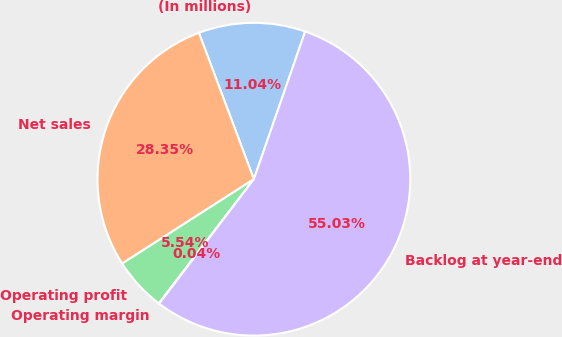Convert chart. <chart><loc_0><loc_0><loc_500><loc_500><pie_chart><fcel>(In millions)<fcel>Net sales<fcel>Operating profit<fcel>Operating margin<fcel>Backlog at year-end<nl><fcel>11.04%<fcel>28.35%<fcel>5.54%<fcel>0.04%<fcel>55.04%<nl></chart> 